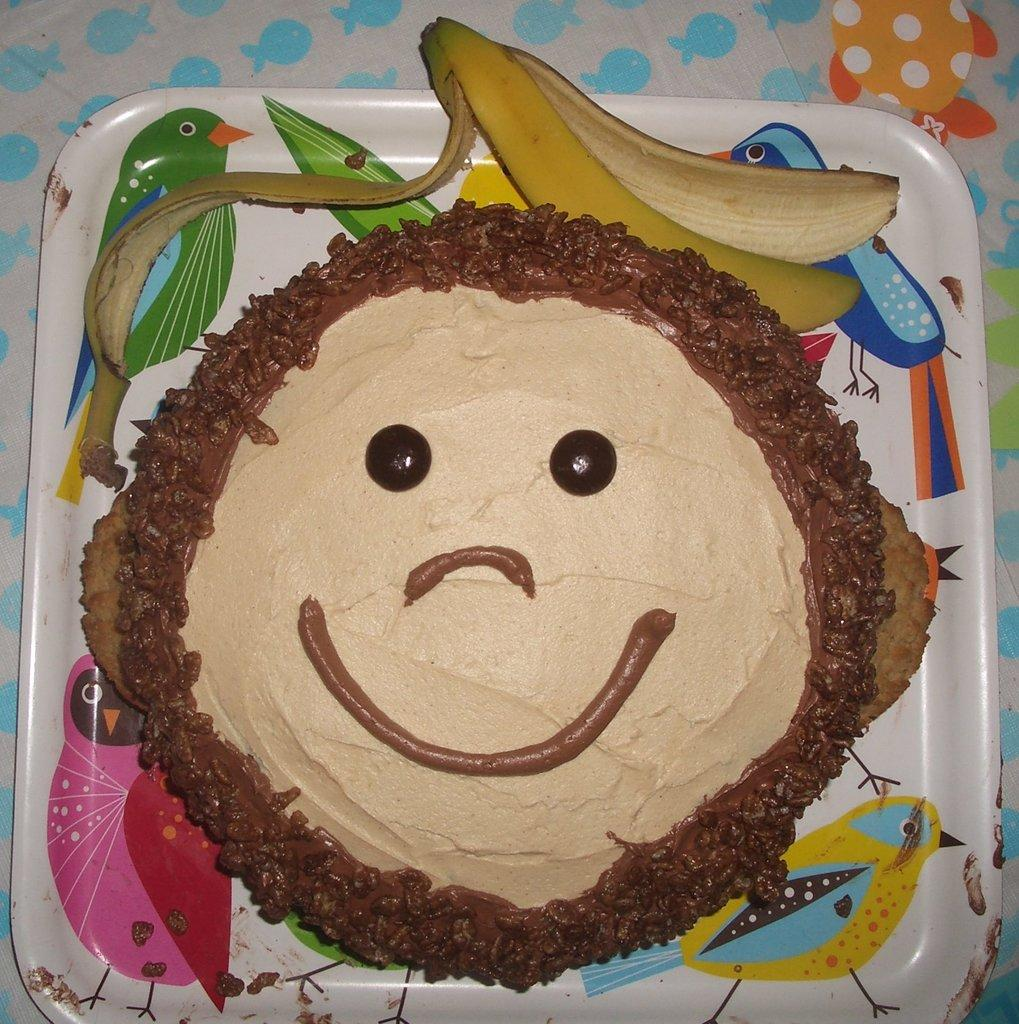What is on the plate in the image? There is a cake on a plate in the image, along with a banana peel. Can you describe the background of the image? The background of the image is colorful. What grade did the cake receive for its taste in the image? There is no indication of a grade or taste evaluation in the image. How does the banana peel contribute to the digestion of the cake in the image? The image does not show any digestion process or interaction between the cake and the banana peel. 